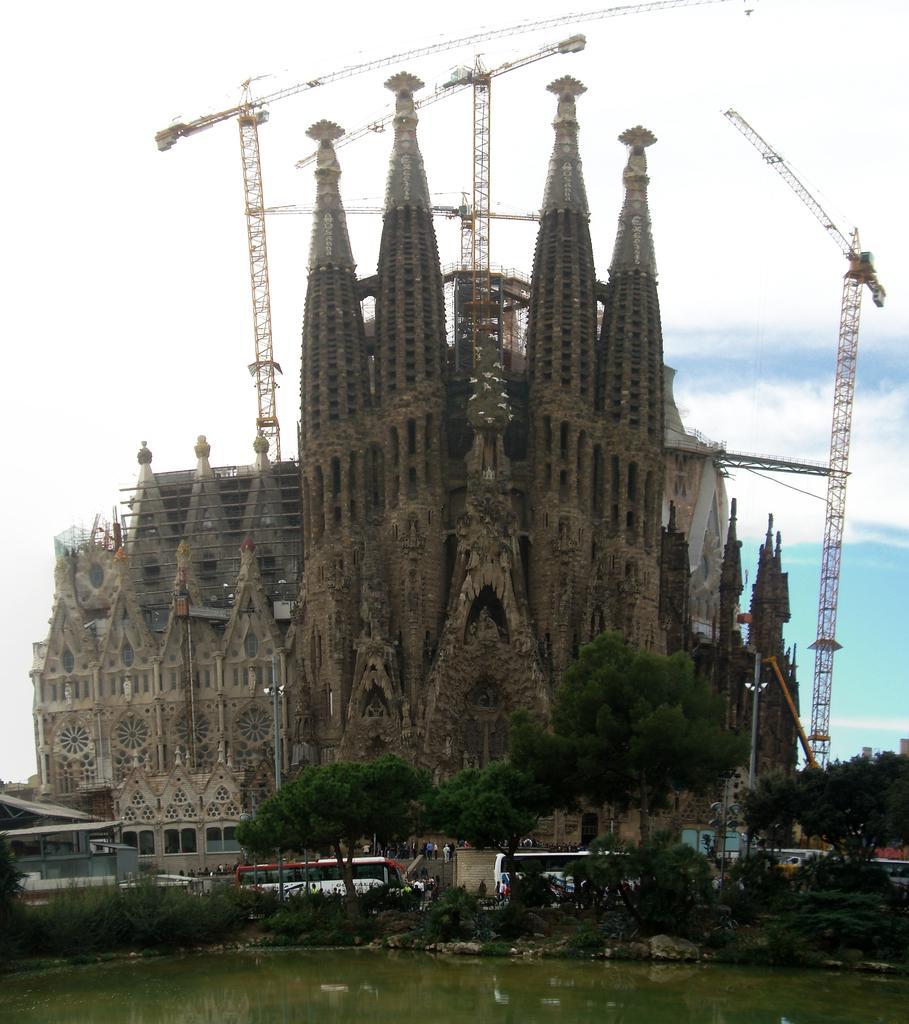Could you give a brief overview of what you see in this image? In this picture we can see water. There are few trees and plants from left to right. We can see a building. There are few cranes. Sky is blue in color and cloudy. 